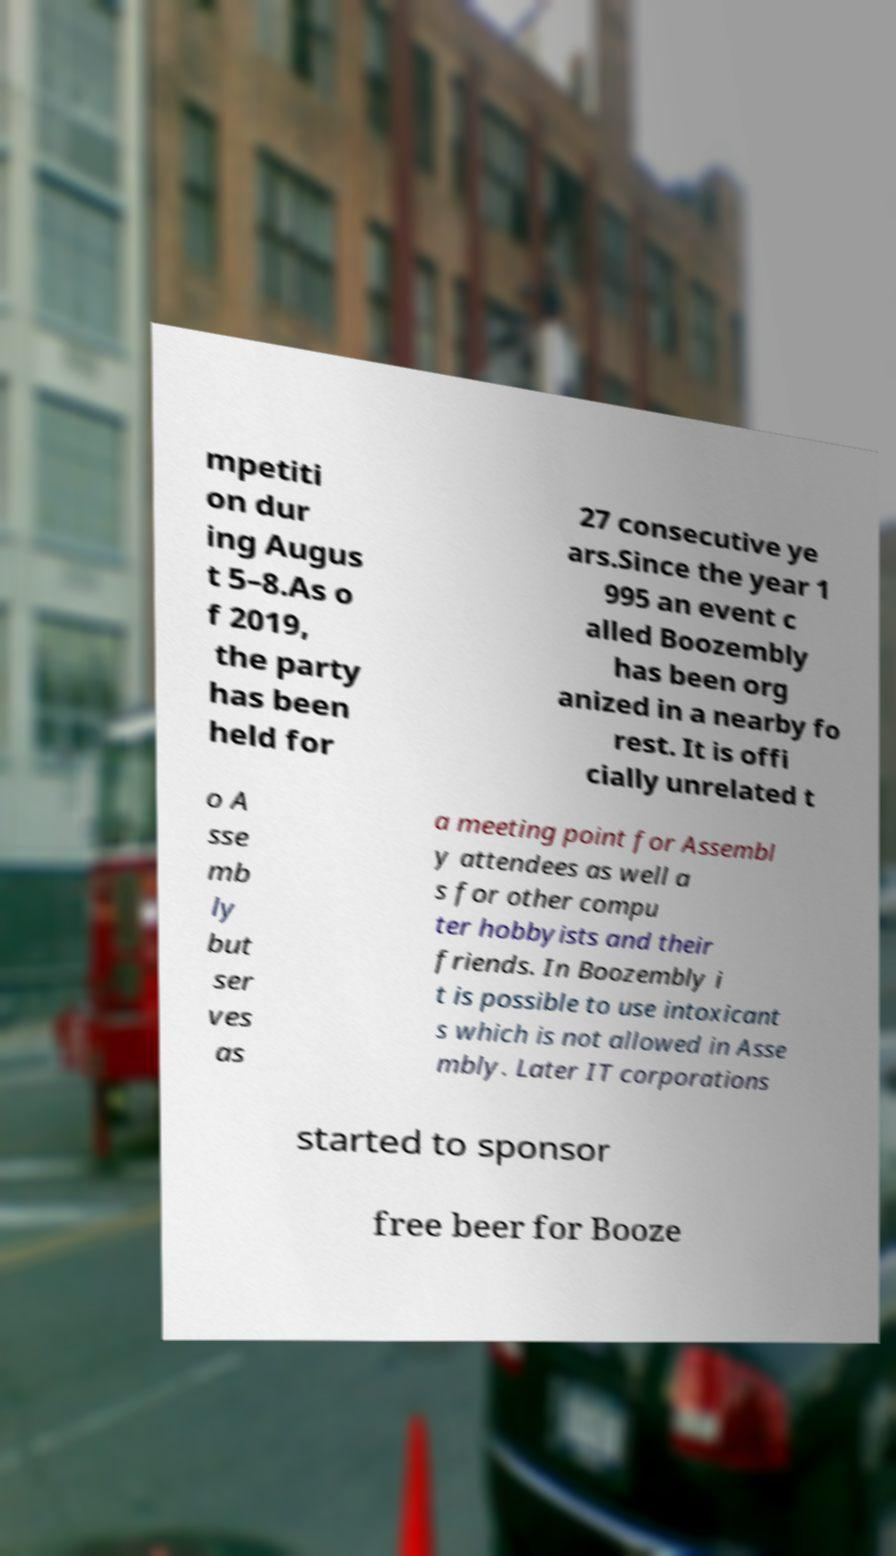Could you extract and type out the text from this image? mpetiti on dur ing Augus t 5–8.As o f 2019, the party has been held for 27 consecutive ye ars.Since the year 1 995 an event c alled Boozembly has been org anized in a nearby fo rest. It is offi cially unrelated t o A sse mb ly but ser ves as a meeting point for Assembl y attendees as well a s for other compu ter hobbyists and their friends. In Boozembly i t is possible to use intoxicant s which is not allowed in Asse mbly. Later IT corporations started to sponsor free beer for Booze 